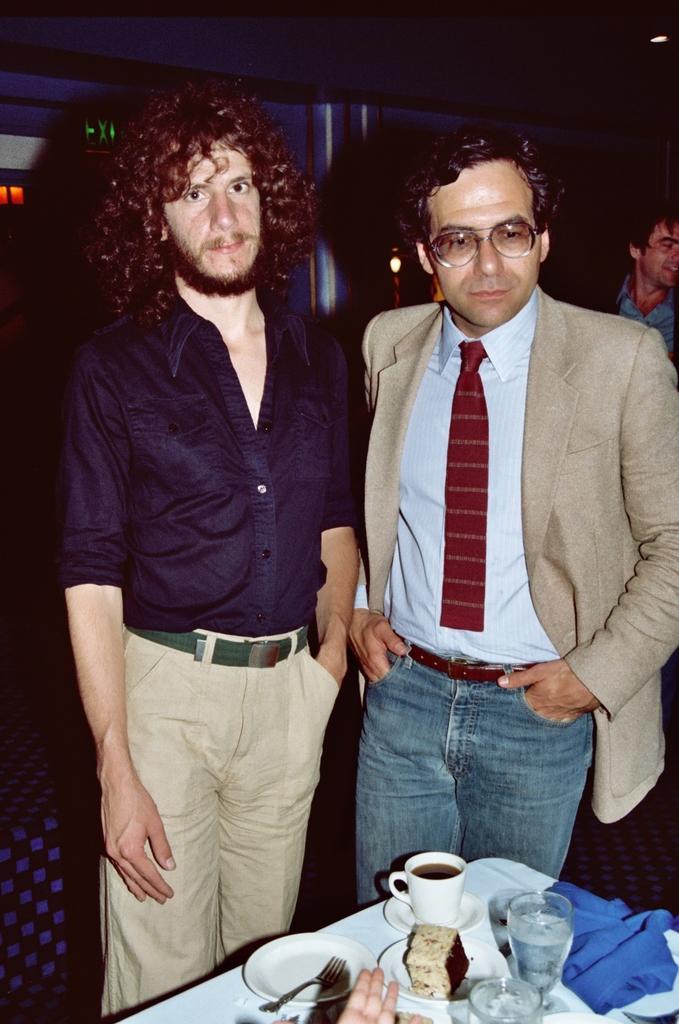Can you describe this image briefly? This picture is taken inside the room. In this image, we can see two men are standing in front of the table. On the table, we can see a water glass, blue color cloth, a plate with some some food, fork, coffee cup. In the middle of the image, we can see fingers of a person. In the background, we can see another person and a pillar. At the top, we can see black color. 